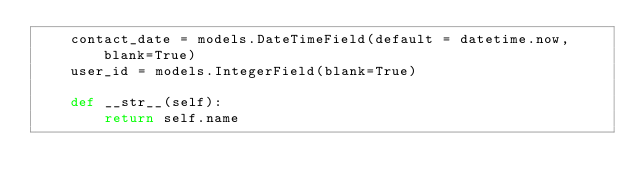<code> <loc_0><loc_0><loc_500><loc_500><_Python_>    contact_date = models.DateTimeField(default = datetime.now, blank=True)
    user_id = models.IntegerField(blank=True)

    def __str__(self):
        return self.name 

</code> 